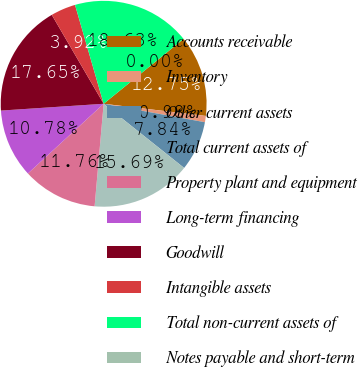Convert chart. <chart><loc_0><loc_0><loc_500><loc_500><pie_chart><fcel>Accounts receivable<fcel>Inventory<fcel>Other current assets<fcel>Total current assets of<fcel>Property plant and equipment<fcel>Long-term financing<fcel>Goodwill<fcel>Intangible assets<fcel>Total non-current assets of<fcel>Notes payable and short-term<nl><fcel>12.74%<fcel>0.98%<fcel>7.84%<fcel>15.68%<fcel>11.76%<fcel>10.78%<fcel>17.64%<fcel>3.92%<fcel>18.62%<fcel>0.0%<nl></chart> 